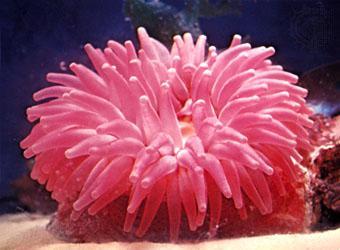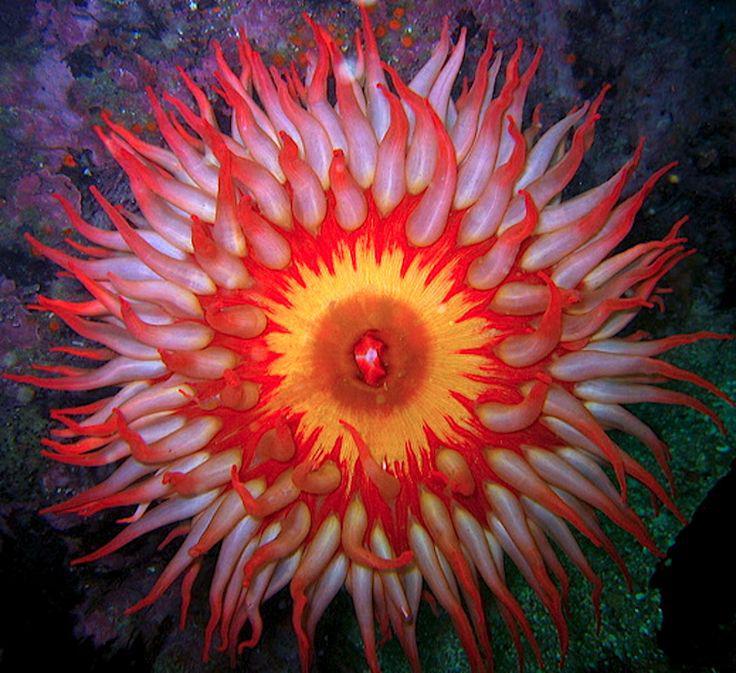The first image is the image on the left, the second image is the image on the right. Given the left and right images, does the statement "An image shows one anemone with ombre-toned reddish-tipped tendrils and a yellow center." hold true? Answer yes or no. Yes. 